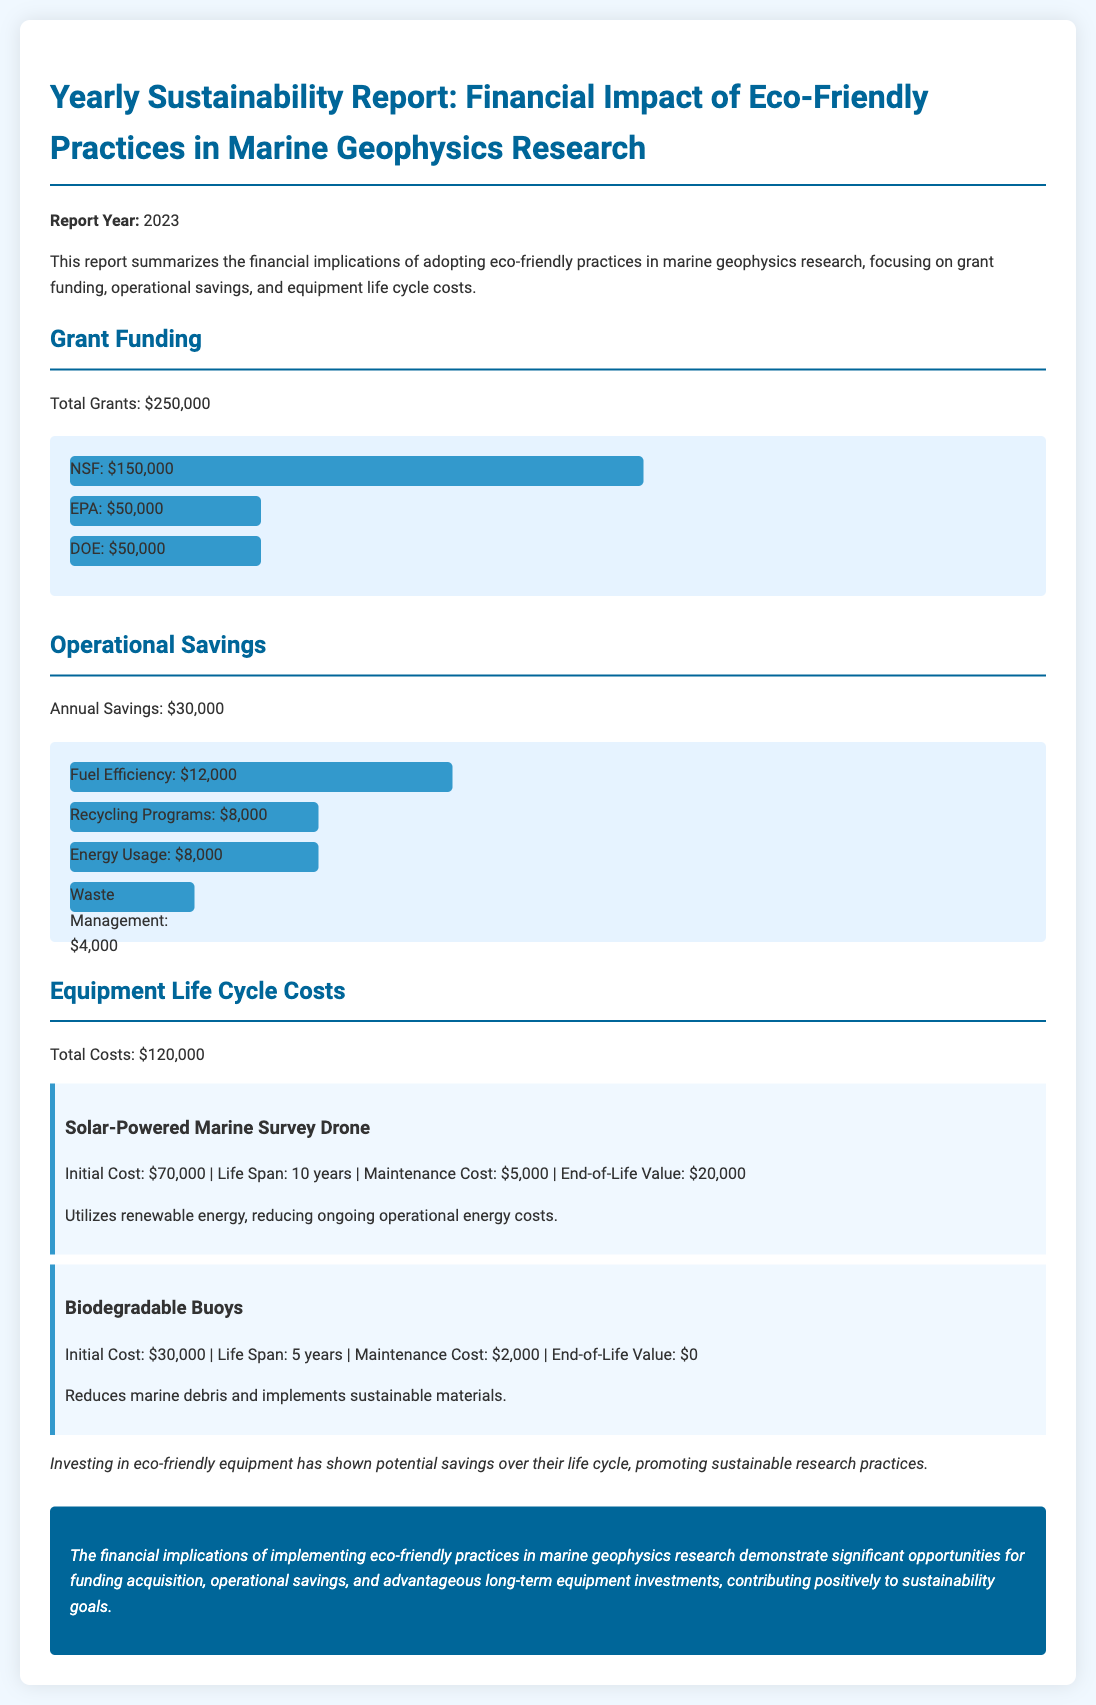What is the total grant funding? The total grant funding is the sum of all individual grants listed, which totals $250,000.
Answer: $250,000 What was the annual savings from operational changes? The annual savings from implementing eco-friendly practices in operations is explicitly mentioned in the report as $30,000.
Answer: $30,000 How much funding did the NSF provide? The document indicates that the National Science Foundation (NSF) provided $150,000 towards the total grant funding.
Answer: $150,000 What is the initial cost of the Solar-Powered Marine Survey Drone? The initial cost for the Solar-Powered Marine Survey Drone is stated in the report as $70,000.
Answer: $70,000 What is the maintenance cost for Biodegradable Buoys? The report specifies that the maintenance cost for Biodegradable Buoys is $2,000.
Answer: $2,000 Calculate the percentage contribution of Fuel Efficiency to the annual savings. The contribution of Fuel Efficiency to annual savings is given as $12,000, which is 40% of the total annual savings of $30,000.
Answer: 40% What is the total life cycle cost for equipment? The report states the total life cycle cost for the equipment as $120,000.
Answer: $120,000 What is the end-of-life value of the Biodegradable Buoys? The end-of-life value for the Biodegradable Buoys is noted in the report as $0.
Answer: $0 What does the conclusion highlight regarding eco-friendly practices? The conclusion emphasizes that eco-friendly practices lead to significant funding opportunities, operational savings, and favorable long-term equipment investments.
Answer: Significant opportunities for funding acquisition, operational savings, and advantageous long-term equipment investments 